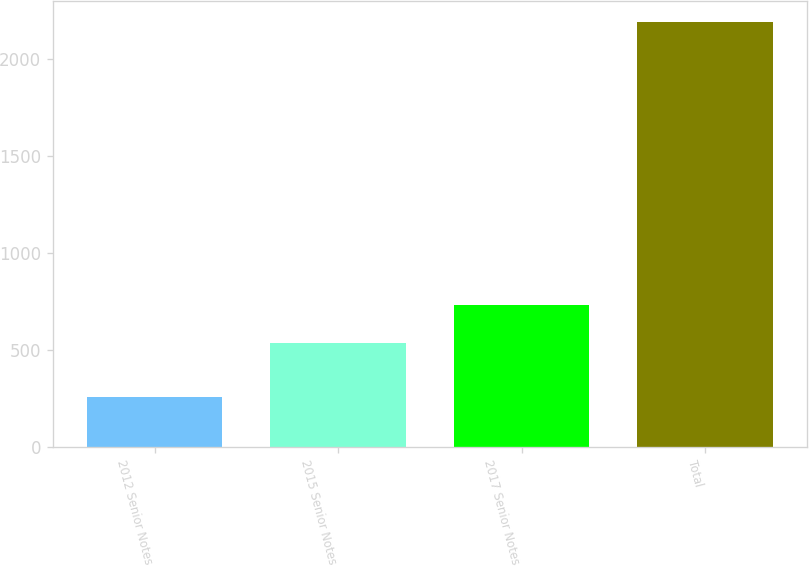<chart> <loc_0><loc_0><loc_500><loc_500><bar_chart><fcel>2012 Senior Notes<fcel>2015 Senior Notes<fcel>2017 Senior Notes<fcel>Total<nl><fcel>256<fcel>536<fcel>729.4<fcel>2190<nl></chart> 